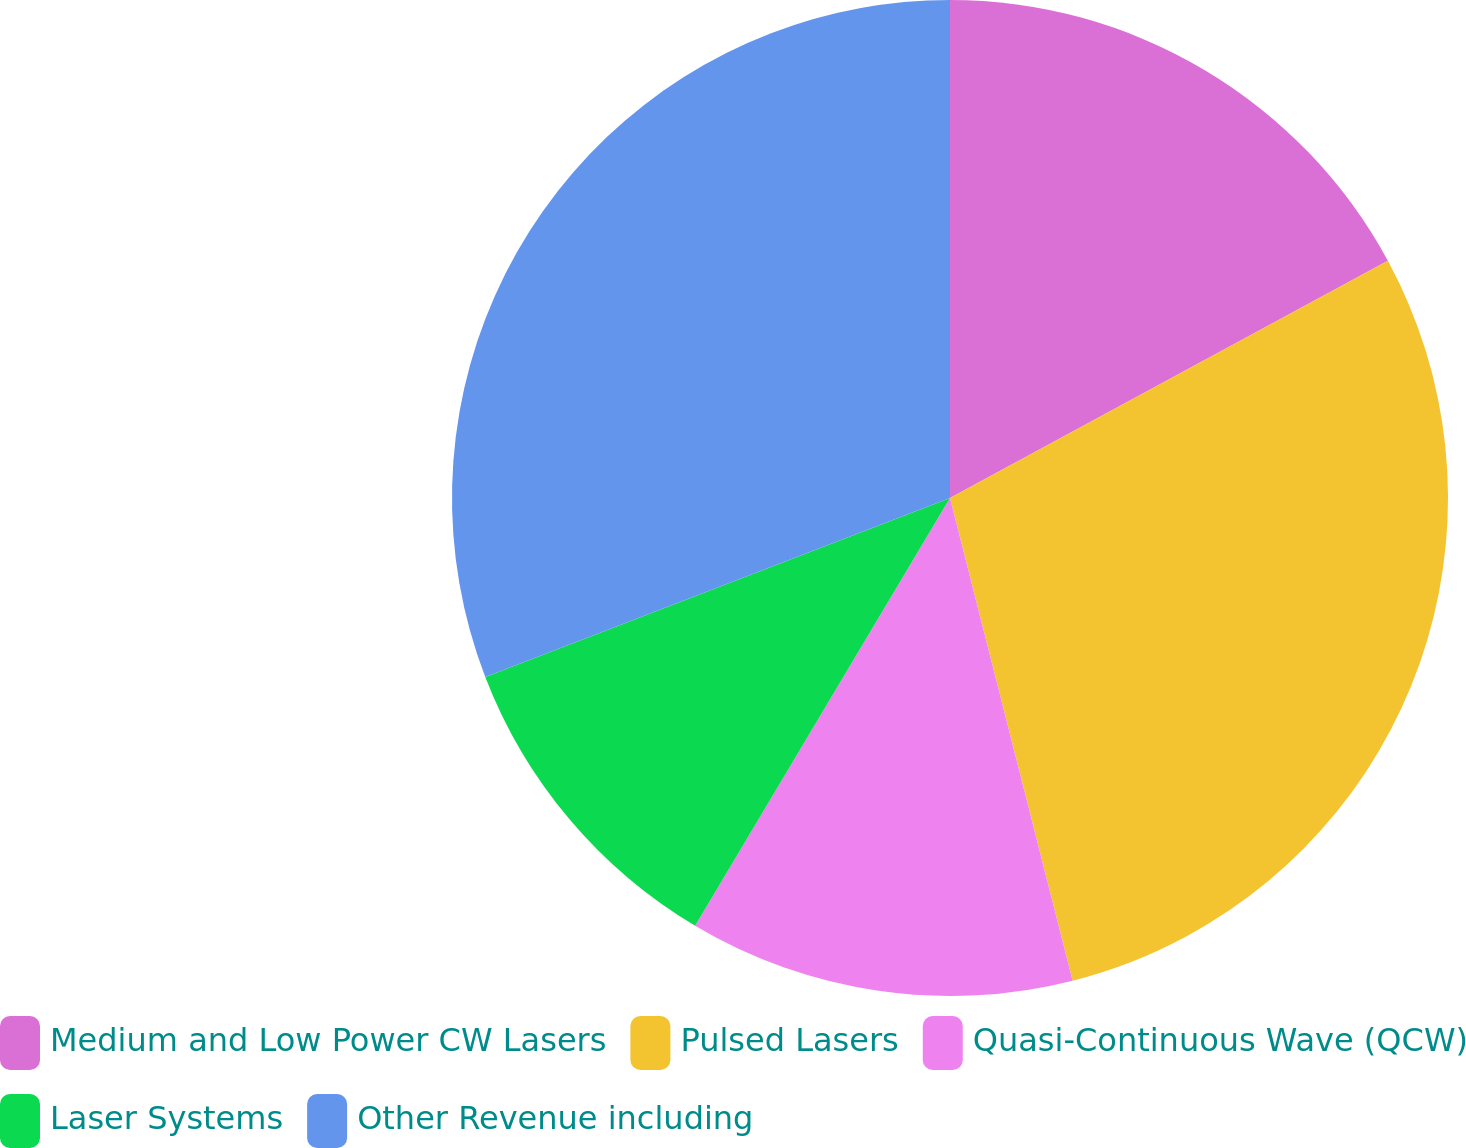Convert chart. <chart><loc_0><loc_0><loc_500><loc_500><pie_chart><fcel>Medium and Low Power CW Lasers<fcel>Pulsed Lasers<fcel>Quasi-Continuous Wave (QCW)<fcel>Laser Systems<fcel>Other Revenue including<nl><fcel>17.1%<fcel>28.94%<fcel>12.51%<fcel>10.6%<fcel>30.85%<nl></chart> 